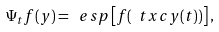<formula> <loc_0><loc_0><loc_500><loc_500>\Psi _ { t } f ( y ) = \ e s p \left [ f ( \ t x c y ( t ) ) \right ] ,</formula> 